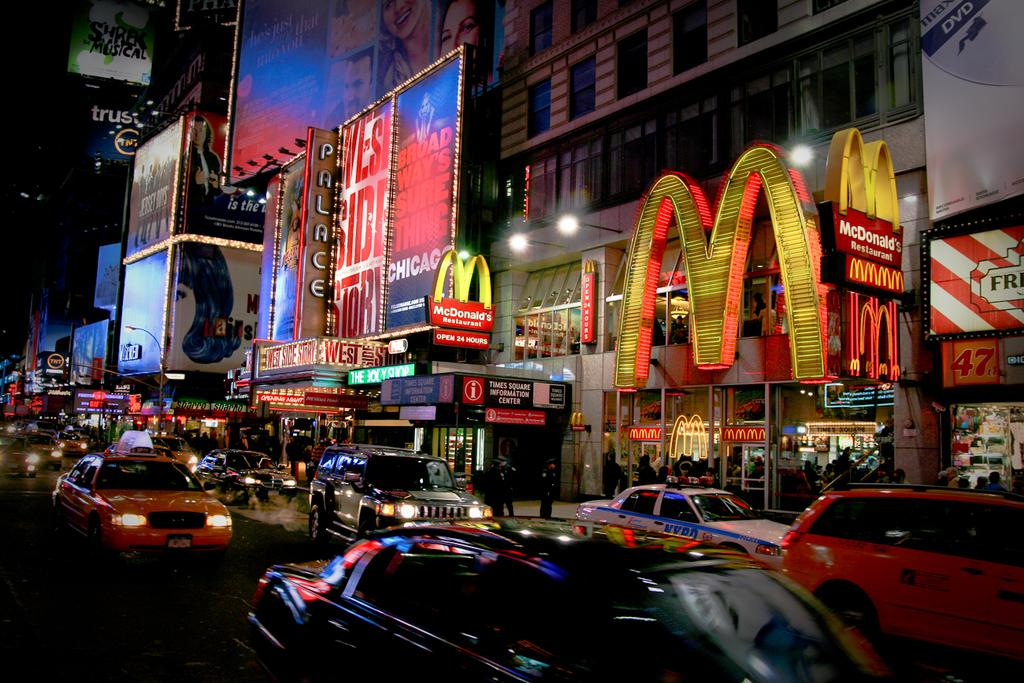<image>
Describe the image concisely. a street with a large letter M on the side 